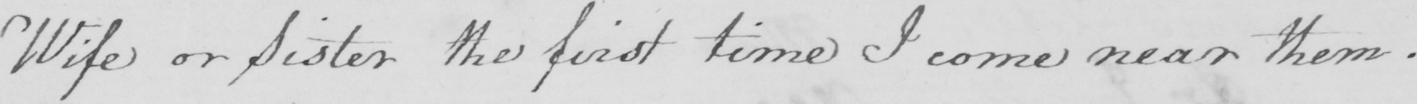Please provide the text content of this handwritten line. Wife or Sister the first time I come near them . 